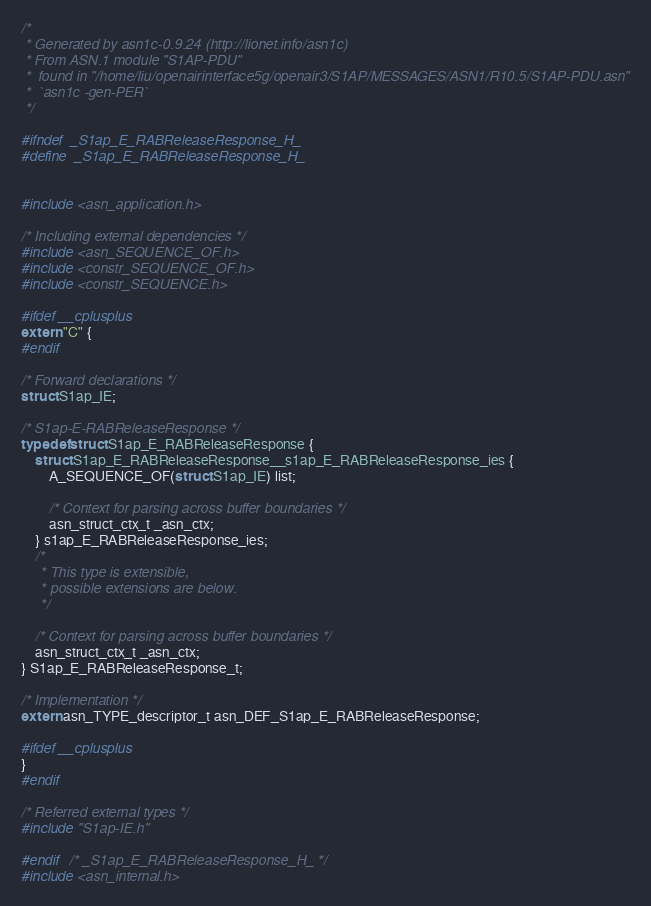Convert code to text. <code><loc_0><loc_0><loc_500><loc_500><_C_>/*
 * Generated by asn1c-0.9.24 (http://lionet.info/asn1c)
 * From ASN.1 module "S1AP-PDU"
 * 	found in "/home/liu/openairinterface5g/openair3/S1AP/MESSAGES/ASN1/R10.5/S1AP-PDU.asn"
 * 	`asn1c -gen-PER`
 */

#ifndef	_S1ap_E_RABReleaseResponse_H_
#define	_S1ap_E_RABReleaseResponse_H_


#include <asn_application.h>

/* Including external dependencies */
#include <asn_SEQUENCE_OF.h>
#include <constr_SEQUENCE_OF.h>
#include <constr_SEQUENCE.h>

#ifdef __cplusplus
extern "C" {
#endif

/* Forward declarations */
struct S1ap_IE;

/* S1ap-E-RABReleaseResponse */
typedef struct S1ap_E_RABReleaseResponse {
	struct S1ap_E_RABReleaseResponse__s1ap_E_RABReleaseResponse_ies {
		A_SEQUENCE_OF(struct S1ap_IE) list;
		
		/* Context for parsing across buffer boundaries */
		asn_struct_ctx_t _asn_ctx;
	} s1ap_E_RABReleaseResponse_ies;
	/*
	 * This type is extensible,
	 * possible extensions are below.
	 */
	
	/* Context for parsing across buffer boundaries */
	asn_struct_ctx_t _asn_ctx;
} S1ap_E_RABReleaseResponse_t;

/* Implementation */
extern asn_TYPE_descriptor_t asn_DEF_S1ap_E_RABReleaseResponse;

#ifdef __cplusplus
}
#endif

/* Referred external types */
#include "S1ap-IE.h"

#endif	/* _S1ap_E_RABReleaseResponse_H_ */
#include <asn_internal.h>
</code> 